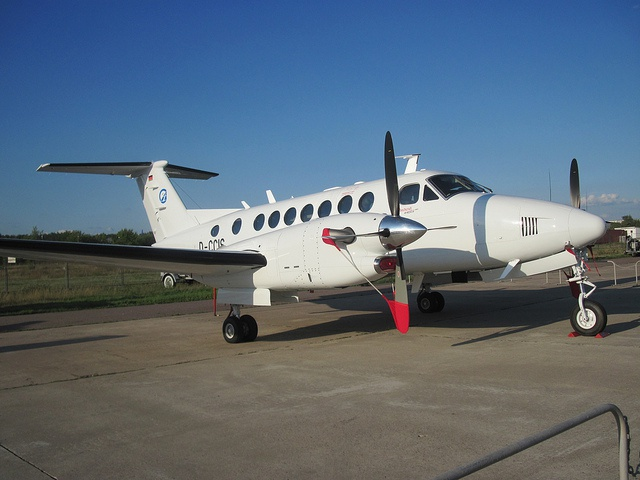Describe the objects in this image and their specific colors. I can see a airplane in darkblue, lightgray, black, gray, and darkgray tones in this image. 